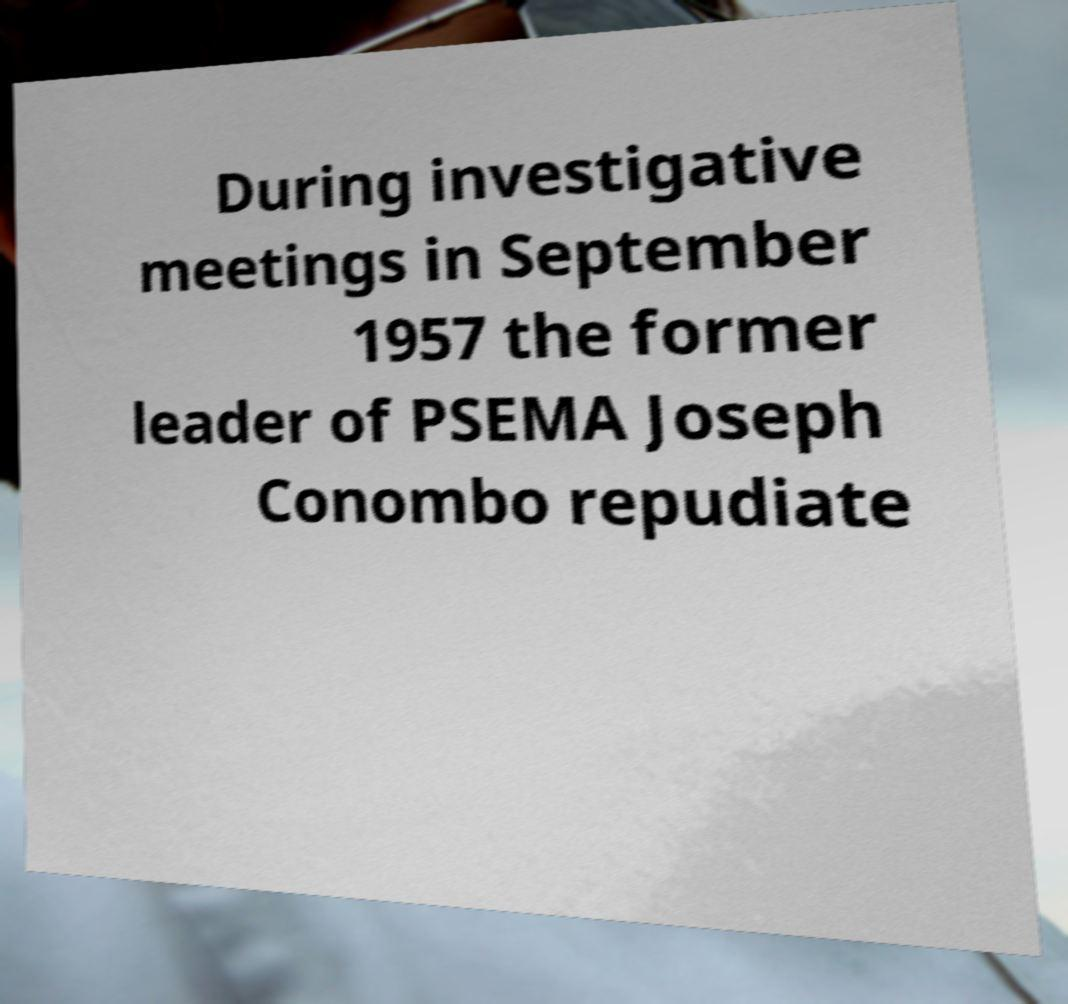Can you accurately transcribe the text from the provided image for me? During investigative meetings in September 1957 the former leader of PSEMA Joseph Conombo repudiate 